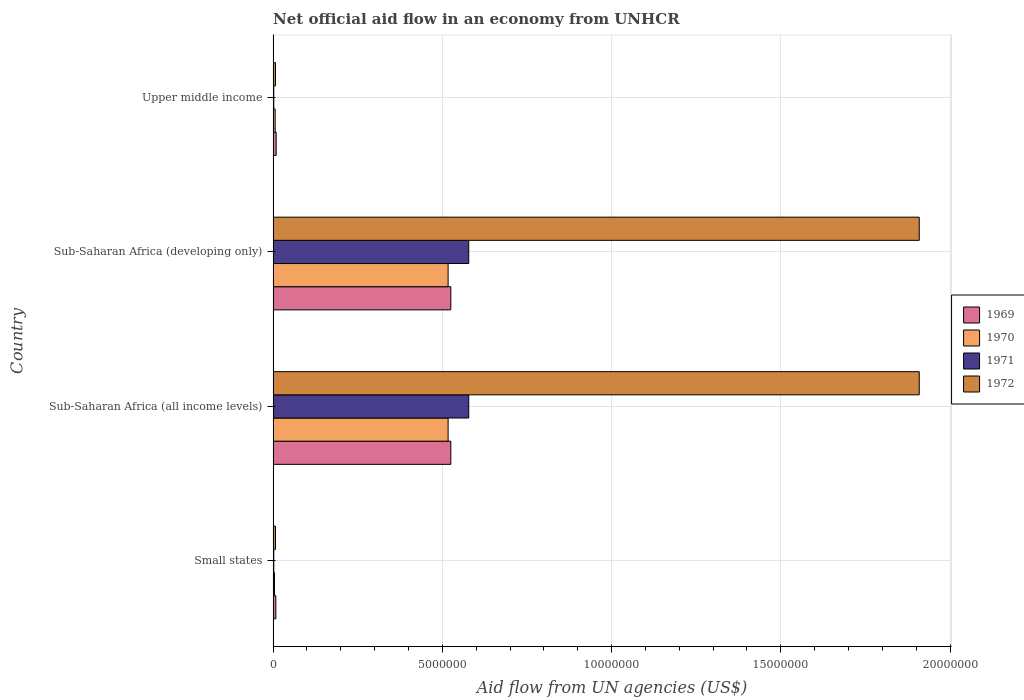How many different coloured bars are there?
Your answer should be compact. 4. How many groups of bars are there?
Make the answer very short. 4. Are the number of bars per tick equal to the number of legend labels?
Offer a terse response. Yes. How many bars are there on the 3rd tick from the top?
Provide a succinct answer. 4. What is the label of the 4th group of bars from the top?
Offer a very short reply. Small states. In how many cases, is the number of bars for a given country not equal to the number of legend labels?
Provide a short and direct response. 0. What is the net official aid flow in 1971 in Sub-Saharan Africa (all income levels)?
Your answer should be very brief. 5.78e+06. Across all countries, what is the maximum net official aid flow in 1969?
Keep it short and to the point. 5.25e+06. In which country was the net official aid flow in 1971 maximum?
Give a very brief answer. Sub-Saharan Africa (all income levels). In which country was the net official aid flow in 1969 minimum?
Provide a succinct answer. Small states. What is the total net official aid flow in 1971 in the graph?
Your response must be concise. 1.16e+07. What is the difference between the net official aid flow in 1969 in Small states and that in Sub-Saharan Africa (all income levels)?
Offer a very short reply. -5.17e+06. What is the difference between the net official aid flow in 1972 in Sub-Saharan Africa (developing only) and the net official aid flow in 1971 in Small states?
Offer a very short reply. 1.91e+07. What is the average net official aid flow in 1969 per country?
Offer a very short reply. 2.67e+06. What is the difference between the net official aid flow in 1972 and net official aid flow in 1970 in Sub-Saharan Africa (developing only)?
Offer a very short reply. 1.39e+07. In how many countries, is the net official aid flow in 1969 greater than 3000000 US$?
Make the answer very short. 2. What is the ratio of the net official aid flow in 1970 in Sub-Saharan Africa (all income levels) to that in Upper middle income?
Offer a terse response. 86.17. Is the net official aid flow in 1969 in Small states less than that in Upper middle income?
Make the answer very short. Yes. What is the difference between the highest and the lowest net official aid flow in 1971?
Offer a very short reply. 5.76e+06. Is the sum of the net official aid flow in 1969 in Sub-Saharan Africa (developing only) and Upper middle income greater than the maximum net official aid flow in 1970 across all countries?
Your answer should be very brief. Yes. What does the 1st bar from the bottom in Sub-Saharan Africa (all income levels) represents?
Keep it short and to the point. 1969. Are all the bars in the graph horizontal?
Your answer should be compact. Yes. What is the difference between two consecutive major ticks on the X-axis?
Your answer should be very brief. 5.00e+06. Are the values on the major ticks of X-axis written in scientific E-notation?
Make the answer very short. No. Does the graph contain grids?
Your answer should be very brief. Yes. How are the legend labels stacked?
Your answer should be very brief. Vertical. What is the title of the graph?
Your answer should be compact. Net official aid flow in an economy from UNHCR. Does "1990" appear as one of the legend labels in the graph?
Give a very brief answer. No. What is the label or title of the X-axis?
Your answer should be very brief. Aid flow from UN agencies (US$). What is the label or title of the Y-axis?
Your answer should be very brief. Country. What is the Aid flow from UN agencies (US$) of 1971 in Small states?
Keep it short and to the point. 2.00e+04. What is the Aid flow from UN agencies (US$) of 1972 in Small states?
Offer a terse response. 7.00e+04. What is the Aid flow from UN agencies (US$) in 1969 in Sub-Saharan Africa (all income levels)?
Provide a succinct answer. 5.25e+06. What is the Aid flow from UN agencies (US$) in 1970 in Sub-Saharan Africa (all income levels)?
Keep it short and to the point. 5.17e+06. What is the Aid flow from UN agencies (US$) of 1971 in Sub-Saharan Africa (all income levels)?
Keep it short and to the point. 5.78e+06. What is the Aid flow from UN agencies (US$) in 1972 in Sub-Saharan Africa (all income levels)?
Provide a succinct answer. 1.91e+07. What is the Aid flow from UN agencies (US$) in 1969 in Sub-Saharan Africa (developing only)?
Give a very brief answer. 5.25e+06. What is the Aid flow from UN agencies (US$) of 1970 in Sub-Saharan Africa (developing only)?
Your answer should be very brief. 5.17e+06. What is the Aid flow from UN agencies (US$) in 1971 in Sub-Saharan Africa (developing only)?
Keep it short and to the point. 5.78e+06. What is the Aid flow from UN agencies (US$) of 1972 in Sub-Saharan Africa (developing only)?
Your answer should be compact. 1.91e+07. What is the Aid flow from UN agencies (US$) of 1969 in Upper middle income?
Offer a terse response. 9.00e+04. What is the Aid flow from UN agencies (US$) of 1972 in Upper middle income?
Ensure brevity in your answer.  7.00e+04. Across all countries, what is the maximum Aid flow from UN agencies (US$) of 1969?
Make the answer very short. 5.25e+06. Across all countries, what is the maximum Aid flow from UN agencies (US$) in 1970?
Ensure brevity in your answer.  5.17e+06. Across all countries, what is the maximum Aid flow from UN agencies (US$) of 1971?
Your answer should be very brief. 5.78e+06. Across all countries, what is the maximum Aid flow from UN agencies (US$) of 1972?
Your answer should be compact. 1.91e+07. Across all countries, what is the minimum Aid flow from UN agencies (US$) of 1969?
Make the answer very short. 8.00e+04. Across all countries, what is the minimum Aid flow from UN agencies (US$) of 1970?
Your response must be concise. 4.00e+04. What is the total Aid flow from UN agencies (US$) in 1969 in the graph?
Your answer should be very brief. 1.07e+07. What is the total Aid flow from UN agencies (US$) of 1970 in the graph?
Offer a very short reply. 1.04e+07. What is the total Aid flow from UN agencies (US$) in 1971 in the graph?
Give a very brief answer. 1.16e+07. What is the total Aid flow from UN agencies (US$) of 1972 in the graph?
Provide a short and direct response. 3.83e+07. What is the difference between the Aid flow from UN agencies (US$) of 1969 in Small states and that in Sub-Saharan Africa (all income levels)?
Your answer should be compact. -5.17e+06. What is the difference between the Aid flow from UN agencies (US$) in 1970 in Small states and that in Sub-Saharan Africa (all income levels)?
Your answer should be compact. -5.13e+06. What is the difference between the Aid flow from UN agencies (US$) in 1971 in Small states and that in Sub-Saharan Africa (all income levels)?
Your answer should be very brief. -5.76e+06. What is the difference between the Aid flow from UN agencies (US$) of 1972 in Small states and that in Sub-Saharan Africa (all income levels)?
Provide a short and direct response. -1.90e+07. What is the difference between the Aid flow from UN agencies (US$) in 1969 in Small states and that in Sub-Saharan Africa (developing only)?
Your answer should be compact. -5.17e+06. What is the difference between the Aid flow from UN agencies (US$) of 1970 in Small states and that in Sub-Saharan Africa (developing only)?
Ensure brevity in your answer.  -5.13e+06. What is the difference between the Aid flow from UN agencies (US$) in 1971 in Small states and that in Sub-Saharan Africa (developing only)?
Your response must be concise. -5.76e+06. What is the difference between the Aid flow from UN agencies (US$) of 1972 in Small states and that in Sub-Saharan Africa (developing only)?
Offer a very short reply. -1.90e+07. What is the difference between the Aid flow from UN agencies (US$) of 1969 in Small states and that in Upper middle income?
Your answer should be very brief. -10000. What is the difference between the Aid flow from UN agencies (US$) in 1972 in Small states and that in Upper middle income?
Make the answer very short. 0. What is the difference between the Aid flow from UN agencies (US$) in 1970 in Sub-Saharan Africa (all income levels) and that in Sub-Saharan Africa (developing only)?
Offer a very short reply. 0. What is the difference between the Aid flow from UN agencies (US$) of 1971 in Sub-Saharan Africa (all income levels) and that in Sub-Saharan Africa (developing only)?
Provide a short and direct response. 0. What is the difference between the Aid flow from UN agencies (US$) in 1969 in Sub-Saharan Africa (all income levels) and that in Upper middle income?
Your answer should be compact. 5.16e+06. What is the difference between the Aid flow from UN agencies (US$) in 1970 in Sub-Saharan Africa (all income levels) and that in Upper middle income?
Keep it short and to the point. 5.11e+06. What is the difference between the Aid flow from UN agencies (US$) in 1971 in Sub-Saharan Africa (all income levels) and that in Upper middle income?
Offer a terse response. 5.76e+06. What is the difference between the Aid flow from UN agencies (US$) in 1972 in Sub-Saharan Africa (all income levels) and that in Upper middle income?
Provide a succinct answer. 1.90e+07. What is the difference between the Aid flow from UN agencies (US$) in 1969 in Sub-Saharan Africa (developing only) and that in Upper middle income?
Your response must be concise. 5.16e+06. What is the difference between the Aid flow from UN agencies (US$) in 1970 in Sub-Saharan Africa (developing only) and that in Upper middle income?
Offer a terse response. 5.11e+06. What is the difference between the Aid flow from UN agencies (US$) of 1971 in Sub-Saharan Africa (developing only) and that in Upper middle income?
Ensure brevity in your answer.  5.76e+06. What is the difference between the Aid flow from UN agencies (US$) in 1972 in Sub-Saharan Africa (developing only) and that in Upper middle income?
Offer a terse response. 1.90e+07. What is the difference between the Aid flow from UN agencies (US$) in 1969 in Small states and the Aid flow from UN agencies (US$) in 1970 in Sub-Saharan Africa (all income levels)?
Your answer should be compact. -5.09e+06. What is the difference between the Aid flow from UN agencies (US$) of 1969 in Small states and the Aid flow from UN agencies (US$) of 1971 in Sub-Saharan Africa (all income levels)?
Ensure brevity in your answer.  -5.70e+06. What is the difference between the Aid flow from UN agencies (US$) of 1969 in Small states and the Aid flow from UN agencies (US$) of 1972 in Sub-Saharan Africa (all income levels)?
Offer a very short reply. -1.90e+07. What is the difference between the Aid flow from UN agencies (US$) of 1970 in Small states and the Aid flow from UN agencies (US$) of 1971 in Sub-Saharan Africa (all income levels)?
Keep it short and to the point. -5.74e+06. What is the difference between the Aid flow from UN agencies (US$) in 1970 in Small states and the Aid flow from UN agencies (US$) in 1972 in Sub-Saharan Africa (all income levels)?
Give a very brief answer. -1.90e+07. What is the difference between the Aid flow from UN agencies (US$) in 1971 in Small states and the Aid flow from UN agencies (US$) in 1972 in Sub-Saharan Africa (all income levels)?
Ensure brevity in your answer.  -1.91e+07. What is the difference between the Aid flow from UN agencies (US$) in 1969 in Small states and the Aid flow from UN agencies (US$) in 1970 in Sub-Saharan Africa (developing only)?
Make the answer very short. -5.09e+06. What is the difference between the Aid flow from UN agencies (US$) of 1969 in Small states and the Aid flow from UN agencies (US$) of 1971 in Sub-Saharan Africa (developing only)?
Your response must be concise. -5.70e+06. What is the difference between the Aid flow from UN agencies (US$) of 1969 in Small states and the Aid flow from UN agencies (US$) of 1972 in Sub-Saharan Africa (developing only)?
Make the answer very short. -1.90e+07. What is the difference between the Aid flow from UN agencies (US$) in 1970 in Small states and the Aid flow from UN agencies (US$) in 1971 in Sub-Saharan Africa (developing only)?
Your answer should be very brief. -5.74e+06. What is the difference between the Aid flow from UN agencies (US$) in 1970 in Small states and the Aid flow from UN agencies (US$) in 1972 in Sub-Saharan Africa (developing only)?
Your answer should be very brief. -1.90e+07. What is the difference between the Aid flow from UN agencies (US$) of 1971 in Small states and the Aid flow from UN agencies (US$) of 1972 in Sub-Saharan Africa (developing only)?
Your answer should be very brief. -1.91e+07. What is the difference between the Aid flow from UN agencies (US$) of 1969 in Small states and the Aid flow from UN agencies (US$) of 1971 in Upper middle income?
Offer a very short reply. 6.00e+04. What is the difference between the Aid flow from UN agencies (US$) of 1970 in Small states and the Aid flow from UN agencies (US$) of 1971 in Upper middle income?
Provide a short and direct response. 2.00e+04. What is the difference between the Aid flow from UN agencies (US$) of 1969 in Sub-Saharan Africa (all income levels) and the Aid flow from UN agencies (US$) of 1970 in Sub-Saharan Africa (developing only)?
Your answer should be very brief. 8.00e+04. What is the difference between the Aid flow from UN agencies (US$) in 1969 in Sub-Saharan Africa (all income levels) and the Aid flow from UN agencies (US$) in 1971 in Sub-Saharan Africa (developing only)?
Provide a short and direct response. -5.30e+05. What is the difference between the Aid flow from UN agencies (US$) in 1969 in Sub-Saharan Africa (all income levels) and the Aid flow from UN agencies (US$) in 1972 in Sub-Saharan Africa (developing only)?
Provide a succinct answer. -1.38e+07. What is the difference between the Aid flow from UN agencies (US$) of 1970 in Sub-Saharan Africa (all income levels) and the Aid flow from UN agencies (US$) of 1971 in Sub-Saharan Africa (developing only)?
Make the answer very short. -6.10e+05. What is the difference between the Aid flow from UN agencies (US$) in 1970 in Sub-Saharan Africa (all income levels) and the Aid flow from UN agencies (US$) in 1972 in Sub-Saharan Africa (developing only)?
Make the answer very short. -1.39e+07. What is the difference between the Aid flow from UN agencies (US$) in 1971 in Sub-Saharan Africa (all income levels) and the Aid flow from UN agencies (US$) in 1972 in Sub-Saharan Africa (developing only)?
Make the answer very short. -1.33e+07. What is the difference between the Aid flow from UN agencies (US$) of 1969 in Sub-Saharan Africa (all income levels) and the Aid flow from UN agencies (US$) of 1970 in Upper middle income?
Offer a terse response. 5.19e+06. What is the difference between the Aid flow from UN agencies (US$) of 1969 in Sub-Saharan Africa (all income levels) and the Aid flow from UN agencies (US$) of 1971 in Upper middle income?
Your answer should be compact. 5.23e+06. What is the difference between the Aid flow from UN agencies (US$) of 1969 in Sub-Saharan Africa (all income levels) and the Aid flow from UN agencies (US$) of 1972 in Upper middle income?
Give a very brief answer. 5.18e+06. What is the difference between the Aid flow from UN agencies (US$) of 1970 in Sub-Saharan Africa (all income levels) and the Aid flow from UN agencies (US$) of 1971 in Upper middle income?
Provide a short and direct response. 5.15e+06. What is the difference between the Aid flow from UN agencies (US$) in 1970 in Sub-Saharan Africa (all income levels) and the Aid flow from UN agencies (US$) in 1972 in Upper middle income?
Keep it short and to the point. 5.10e+06. What is the difference between the Aid flow from UN agencies (US$) in 1971 in Sub-Saharan Africa (all income levels) and the Aid flow from UN agencies (US$) in 1972 in Upper middle income?
Provide a short and direct response. 5.71e+06. What is the difference between the Aid flow from UN agencies (US$) in 1969 in Sub-Saharan Africa (developing only) and the Aid flow from UN agencies (US$) in 1970 in Upper middle income?
Give a very brief answer. 5.19e+06. What is the difference between the Aid flow from UN agencies (US$) in 1969 in Sub-Saharan Africa (developing only) and the Aid flow from UN agencies (US$) in 1971 in Upper middle income?
Provide a succinct answer. 5.23e+06. What is the difference between the Aid flow from UN agencies (US$) of 1969 in Sub-Saharan Africa (developing only) and the Aid flow from UN agencies (US$) of 1972 in Upper middle income?
Keep it short and to the point. 5.18e+06. What is the difference between the Aid flow from UN agencies (US$) of 1970 in Sub-Saharan Africa (developing only) and the Aid flow from UN agencies (US$) of 1971 in Upper middle income?
Make the answer very short. 5.15e+06. What is the difference between the Aid flow from UN agencies (US$) of 1970 in Sub-Saharan Africa (developing only) and the Aid flow from UN agencies (US$) of 1972 in Upper middle income?
Your answer should be very brief. 5.10e+06. What is the difference between the Aid flow from UN agencies (US$) in 1971 in Sub-Saharan Africa (developing only) and the Aid flow from UN agencies (US$) in 1972 in Upper middle income?
Your response must be concise. 5.71e+06. What is the average Aid flow from UN agencies (US$) of 1969 per country?
Your answer should be very brief. 2.67e+06. What is the average Aid flow from UN agencies (US$) in 1970 per country?
Give a very brief answer. 2.61e+06. What is the average Aid flow from UN agencies (US$) of 1971 per country?
Your answer should be compact. 2.90e+06. What is the average Aid flow from UN agencies (US$) in 1972 per country?
Offer a terse response. 9.58e+06. What is the difference between the Aid flow from UN agencies (US$) in 1969 and Aid flow from UN agencies (US$) in 1972 in Small states?
Your response must be concise. 10000. What is the difference between the Aid flow from UN agencies (US$) of 1969 and Aid flow from UN agencies (US$) of 1971 in Sub-Saharan Africa (all income levels)?
Ensure brevity in your answer.  -5.30e+05. What is the difference between the Aid flow from UN agencies (US$) of 1969 and Aid flow from UN agencies (US$) of 1972 in Sub-Saharan Africa (all income levels)?
Ensure brevity in your answer.  -1.38e+07. What is the difference between the Aid flow from UN agencies (US$) in 1970 and Aid flow from UN agencies (US$) in 1971 in Sub-Saharan Africa (all income levels)?
Your response must be concise. -6.10e+05. What is the difference between the Aid flow from UN agencies (US$) in 1970 and Aid flow from UN agencies (US$) in 1972 in Sub-Saharan Africa (all income levels)?
Keep it short and to the point. -1.39e+07. What is the difference between the Aid flow from UN agencies (US$) in 1971 and Aid flow from UN agencies (US$) in 1972 in Sub-Saharan Africa (all income levels)?
Your answer should be very brief. -1.33e+07. What is the difference between the Aid flow from UN agencies (US$) of 1969 and Aid flow from UN agencies (US$) of 1970 in Sub-Saharan Africa (developing only)?
Your response must be concise. 8.00e+04. What is the difference between the Aid flow from UN agencies (US$) in 1969 and Aid flow from UN agencies (US$) in 1971 in Sub-Saharan Africa (developing only)?
Your answer should be compact. -5.30e+05. What is the difference between the Aid flow from UN agencies (US$) in 1969 and Aid flow from UN agencies (US$) in 1972 in Sub-Saharan Africa (developing only)?
Offer a very short reply. -1.38e+07. What is the difference between the Aid flow from UN agencies (US$) in 1970 and Aid flow from UN agencies (US$) in 1971 in Sub-Saharan Africa (developing only)?
Keep it short and to the point. -6.10e+05. What is the difference between the Aid flow from UN agencies (US$) of 1970 and Aid flow from UN agencies (US$) of 1972 in Sub-Saharan Africa (developing only)?
Provide a short and direct response. -1.39e+07. What is the difference between the Aid flow from UN agencies (US$) of 1971 and Aid flow from UN agencies (US$) of 1972 in Sub-Saharan Africa (developing only)?
Provide a succinct answer. -1.33e+07. What is the difference between the Aid flow from UN agencies (US$) of 1969 and Aid flow from UN agencies (US$) of 1972 in Upper middle income?
Ensure brevity in your answer.  2.00e+04. What is the difference between the Aid flow from UN agencies (US$) of 1970 and Aid flow from UN agencies (US$) of 1971 in Upper middle income?
Provide a succinct answer. 4.00e+04. What is the difference between the Aid flow from UN agencies (US$) in 1971 and Aid flow from UN agencies (US$) in 1972 in Upper middle income?
Your response must be concise. -5.00e+04. What is the ratio of the Aid flow from UN agencies (US$) in 1969 in Small states to that in Sub-Saharan Africa (all income levels)?
Your answer should be very brief. 0.02. What is the ratio of the Aid flow from UN agencies (US$) in 1970 in Small states to that in Sub-Saharan Africa (all income levels)?
Your answer should be compact. 0.01. What is the ratio of the Aid flow from UN agencies (US$) in 1971 in Small states to that in Sub-Saharan Africa (all income levels)?
Your response must be concise. 0. What is the ratio of the Aid flow from UN agencies (US$) of 1972 in Small states to that in Sub-Saharan Africa (all income levels)?
Keep it short and to the point. 0. What is the ratio of the Aid flow from UN agencies (US$) in 1969 in Small states to that in Sub-Saharan Africa (developing only)?
Your answer should be compact. 0.02. What is the ratio of the Aid flow from UN agencies (US$) in 1970 in Small states to that in Sub-Saharan Africa (developing only)?
Offer a very short reply. 0.01. What is the ratio of the Aid flow from UN agencies (US$) in 1971 in Small states to that in Sub-Saharan Africa (developing only)?
Provide a succinct answer. 0. What is the ratio of the Aid flow from UN agencies (US$) in 1972 in Small states to that in Sub-Saharan Africa (developing only)?
Provide a short and direct response. 0. What is the ratio of the Aid flow from UN agencies (US$) in 1972 in Small states to that in Upper middle income?
Your answer should be very brief. 1. What is the ratio of the Aid flow from UN agencies (US$) in 1971 in Sub-Saharan Africa (all income levels) to that in Sub-Saharan Africa (developing only)?
Your answer should be compact. 1. What is the ratio of the Aid flow from UN agencies (US$) of 1972 in Sub-Saharan Africa (all income levels) to that in Sub-Saharan Africa (developing only)?
Keep it short and to the point. 1. What is the ratio of the Aid flow from UN agencies (US$) of 1969 in Sub-Saharan Africa (all income levels) to that in Upper middle income?
Provide a succinct answer. 58.33. What is the ratio of the Aid flow from UN agencies (US$) in 1970 in Sub-Saharan Africa (all income levels) to that in Upper middle income?
Offer a terse response. 86.17. What is the ratio of the Aid flow from UN agencies (US$) of 1971 in Sub-Saharan Africa (all income levels) to that in Upper middle income?
Your response must be concise. 289. What is the ratio of the Aid flow from UN agencies (US$) of 1972 in Sub-Saharan Africa (all income levels) to that in Upper middle income?
Give a very brief answer. 272.71. What is the ratio of the Aid flow from UN agencies (US$) in 1969 in Sub-Saharan Africa (developing only) to that in Upper middle income?
Offer a very short reply. 58.33. What is the ratio of the Aid flow from UN agencies (US$) in 1970 in Sub-Saharan Africa (developing only) to that in Upper middle income?
Ensure brevity in your answer.  86.17. What is the ratio of the Aid flow from UN agencies (US$) of 1971 in Sub-Saharan Africa (developing only) to that in Upper middle income?
Your response must be concise. 289. What is the ratio of the Aid flow from UN agencies (US$) of 1972 in Sub-Saharan Africa (developing only) to that in Upper middle income?
Offer a terse response. 272.71. What is the difference between the highest and the second highest Aid flow from UN agencies (US$) of 1970?
Make the answer very short. 0. What is the difference between the highest and the second highest Aid flow from UN agencies (US$) of 1972?
Provide a succinct answer. 0. What is the difference between the highest and the lowest Aid flow from UN agencies (US$) of 1969?
Keep it short and to the point. 5.17e+06. What is the difference between the highest and the lowest Aid flow from UN agencies (US$) in 1970?
Your answer should be very brief. 5.13e+06. What is the difference between the highest and the lowest Aid flow from UN agencies (US$) of 1971?
Offer a very short reply. 5.76e+06. What is the difference between the highest and the lowest Aid flow from UN agencies (US$) of 1972?
Offer a very short reply. 1.90e+07. 